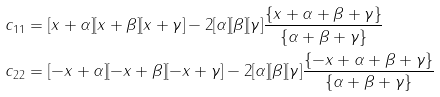<formula> <loc_0><loc_0><loc_500><loc_500>c _ { 1 1 } & = [ x + \alpha ] [ x + \beta ] [ x + \gamma ] - 2 [ \alpha ] [ \beta ] [ \gamma ] \frac { \{ x + \alpha + \beta + \gamma \} } { \{ \alpha + \beta + \gamma \} } \\ c _ { 2 2 } & = [ - x + \alpha ] [ - x + \beta ] [ - x + \gamma ] - 2 [ \alpha ] [ \beta ] [ \gamma ] \frac { \{ - x + \alpha + \beta + \gamma \} } { \{ \alpha + \beta + \gamma \} }</formula> 